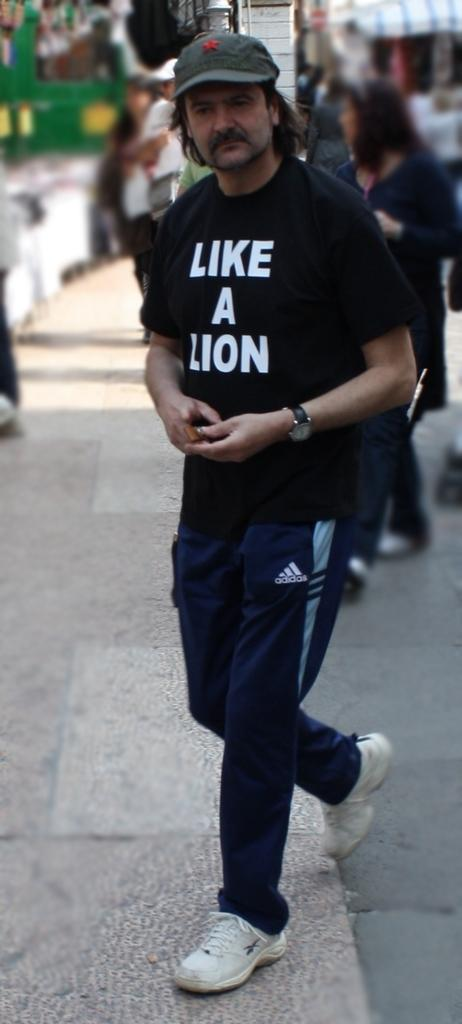What is the person in the image wearing? The person in the image is wearing a black t-shirt. What is the person in the image doing? The person is walking on a footpath. Can you describe the background of the image? The background of the image is blurred, and there are other persons visible. What is the price of the letters on the person's t-shirt in the image? There are no letters visible on the person's t-shirt in the image, and therefore no price can be determined. Can you tell me the name of the judge in the image? There is no judge present in the image. 